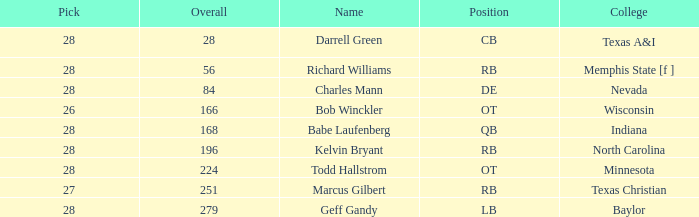What is the highest pick of the player from texas a&i with an overall less than 28? None. 